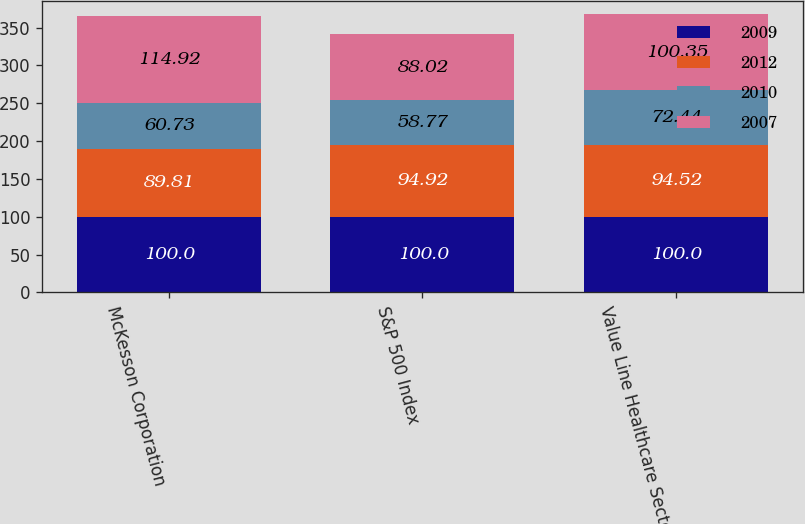<chart> <loc_0><loc_0><loc_500><loc_500><stacked_bar_chart><ecel><fcel>McKesson Corporation<fcel>S&P 500 Index<fcel>Value Line Healthcare Sector<nl><fcel>2009<fcel>100<fcel>100<fcel>100<nl><fcel>2012<fcel>89.81<fcel>94.92<fcel>94.52<nl><fcel>2010<fcel>60.73<fcel>58.77<fcel>72.44<nl><fcel>2007<fcel>114.92<fcel>88.02<fcel>100.35<nl></chart> 